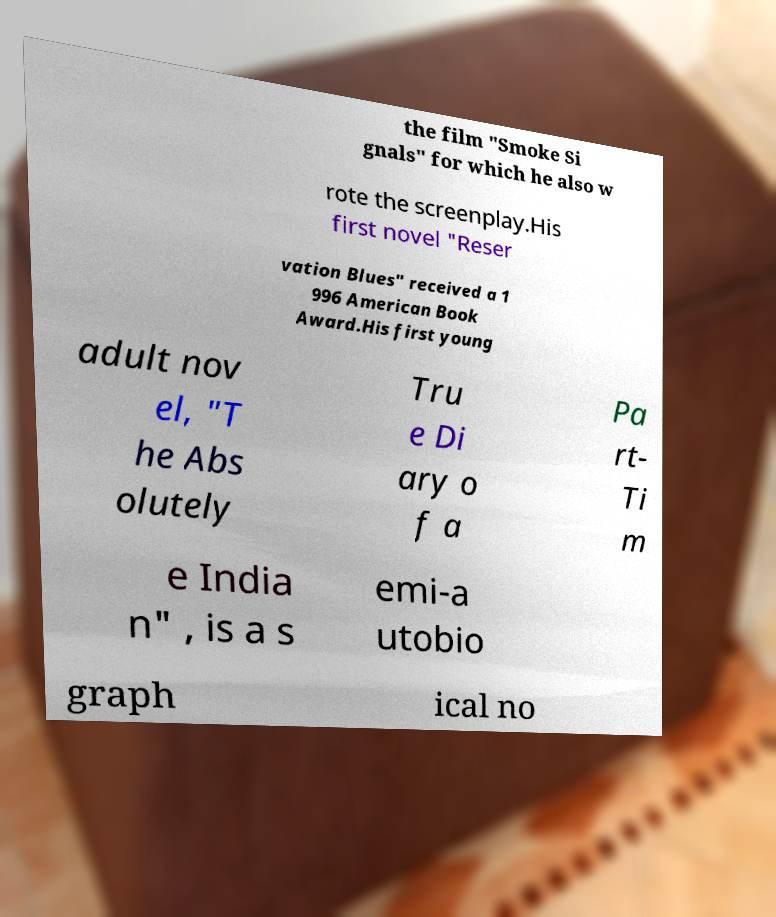There's text embedded in this image that I need extracted. Can you transcribe it verbatim? the film "Smoke Si gnals" for which he also w rote the screenplay.His first novel "Reser vation Blues" received a 1 996 American Book Award.His first young adult nov el, "T he Abs olutely Tru e Di ary o f a Pa rt- Ti m e India n" , is a s emi-a utobio graph ical no 